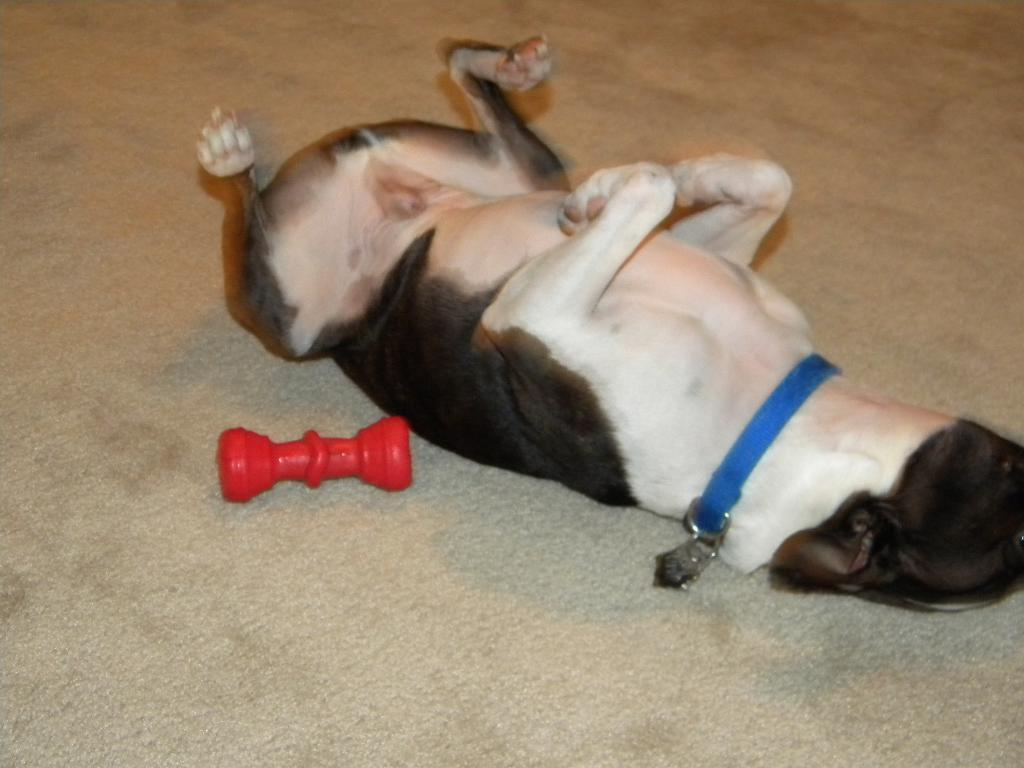What type of animal can be seen in the image? There is a dog in the image. What is the dog doing in the image? The dog is lying on the floor. Are there any toys visible in the image? Yes, there is a red color toy in the image. What type of comb is the dog using to groom its fur in the image? There is no comb present in the image, and the dog is not grooming its fur. 